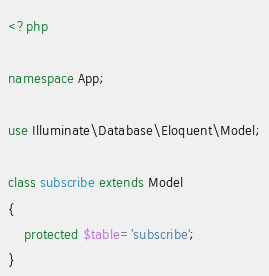Convert code to text. <code><loc_0><loc_0><loc_500><loc_500><_PHP_><?php

namespace App;

use Illuminate\Database\Eloquent\Model;

class subscribe extends Model
{
    protected $table='subscribe';
}
</code> 